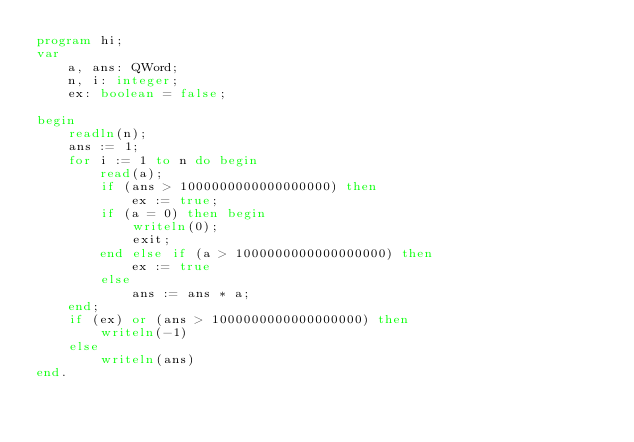<code> <loc_0><loc_0><loc_500><loc_500><_Pascal_>program hi;
var 
    a, ans: QWord;
    n, i: integer;
    ex: boolean = false;

begin
    readln(n);
    ans := 1;
    for i := 1 to n do begin
        read(a);
        if (ans > 1000000000000000000) then 
            ex := true;
        if (a = 0) then begin
            writeln(0);
            exit;
        end else if (a > 1000000000000000000) then 
            ex := true
        else
            ans := ans * a;
    end;
    if (ex) or (ans > 1000000000000000000) then 
        writeln(-1)
    else 
        writeln(ans)
end.</code> 